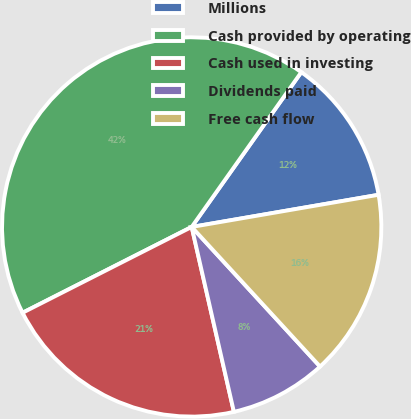Convert chart to OTSL. <chart><loc_0><loc_0><loc_500><loc_500><pie_chart><fcel>Millions<fcel>Cash provided by operating<fcel>Cash used in investing<fcel>Dividends paid<fcel>Free cash flow<nl><fcel>12.48%<fcel>42.28%<fcel>21.1%<fcel>8.26%<fcel>15.88%<nl></chart> 